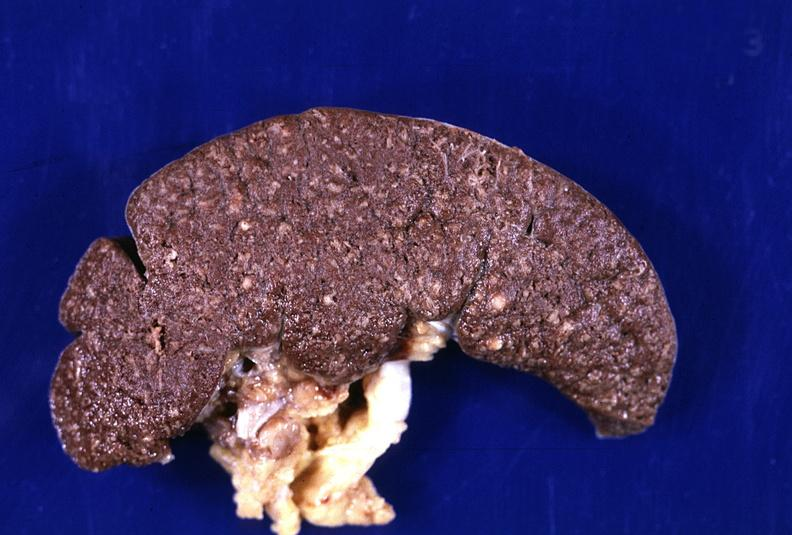does cervical leiomyoma show spleen, tuberculosis, granulomas?
Answer the question using a single word or phrase. No 